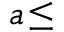<formula> <loc_0><loc_0><loc_500><loc_500>a \, \leq</formula> 